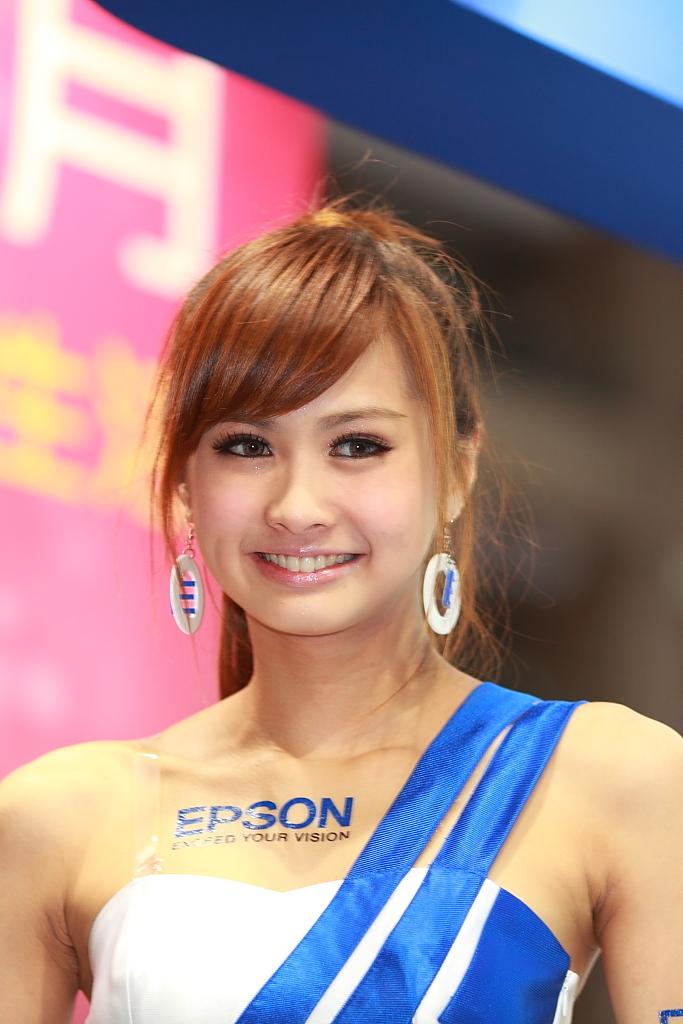What word is on the womans chest?
Your response must be concise. Epson. 